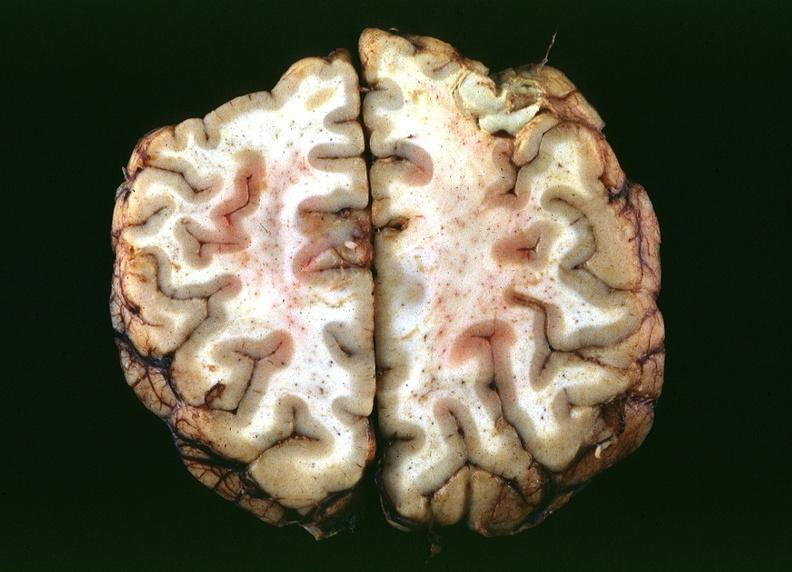what does this image show?
Answer the question using a single word or phrase. Toxoplasmosis 